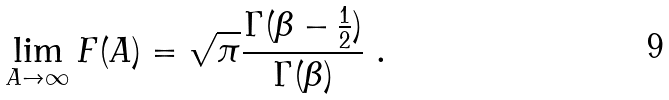Convert formula to latex. <formula><loc_0><loc_0><loc_500><loc_500>\lim _ { A \to \infty } F ( A ) = \sqrt { \pi } \frac { \Gamma ( \beta - \frac { 1 } { 2 } ) } { \Gamma ( \beta ) } \ .</formula> 